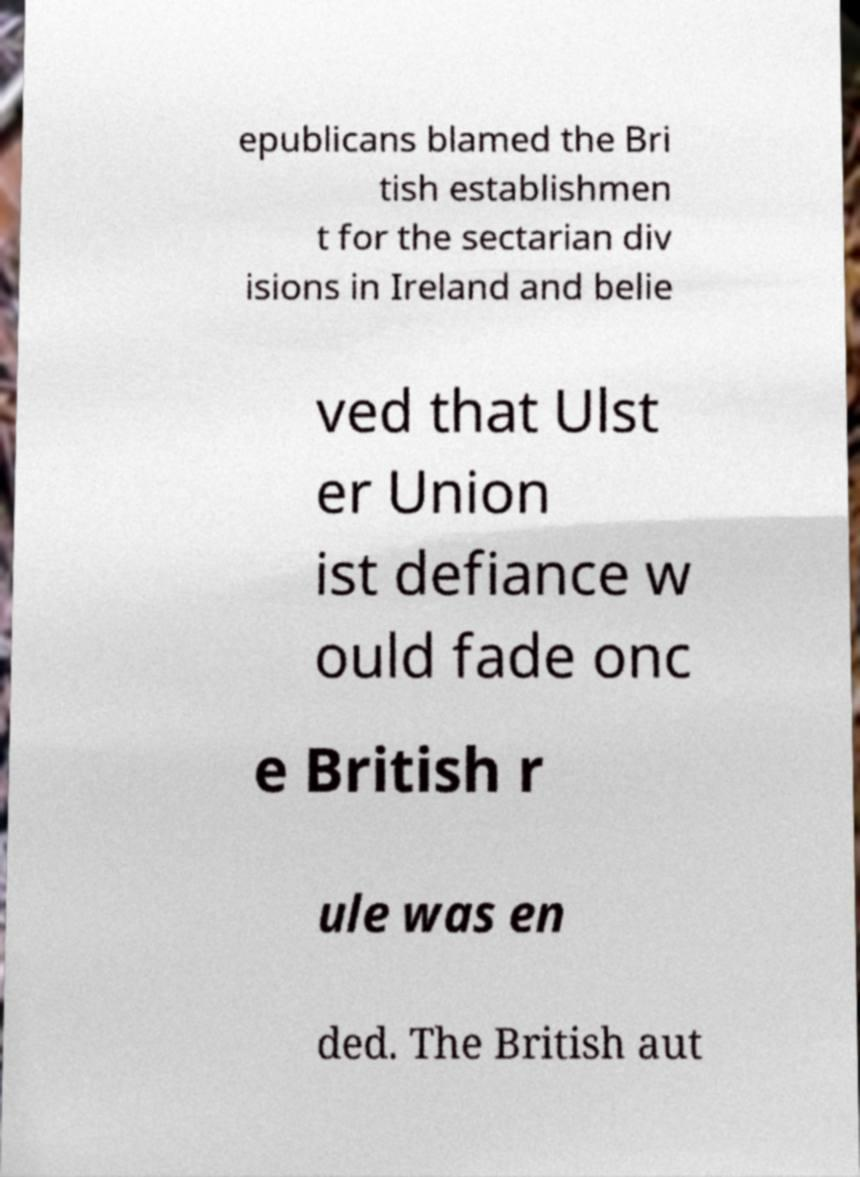Could you assist in decoding the text presented in this image and type it out clearly? epublicans blamed the Bri tish establishmen t for the sectarian div isions in Ireland and belie ved that Ulst er Union ist defiance w ould fade onc e British r ule was en ded. The British aut 